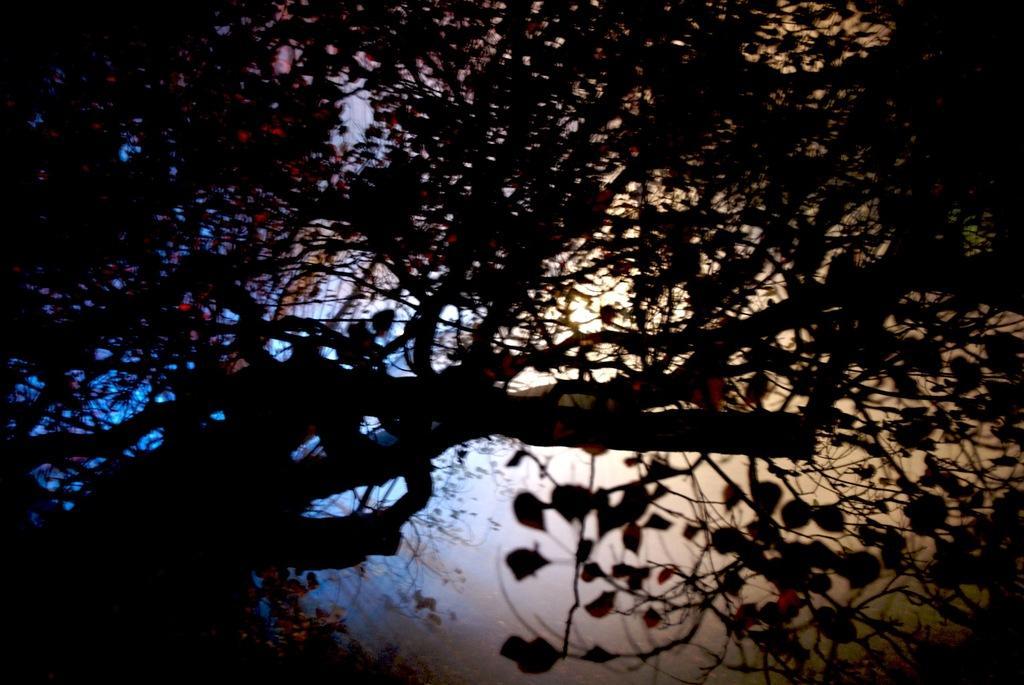Can you describe this image briefly? There is a tree which is having leaves and branches. In the background, there are trees and there are clouds in the blue sky. 